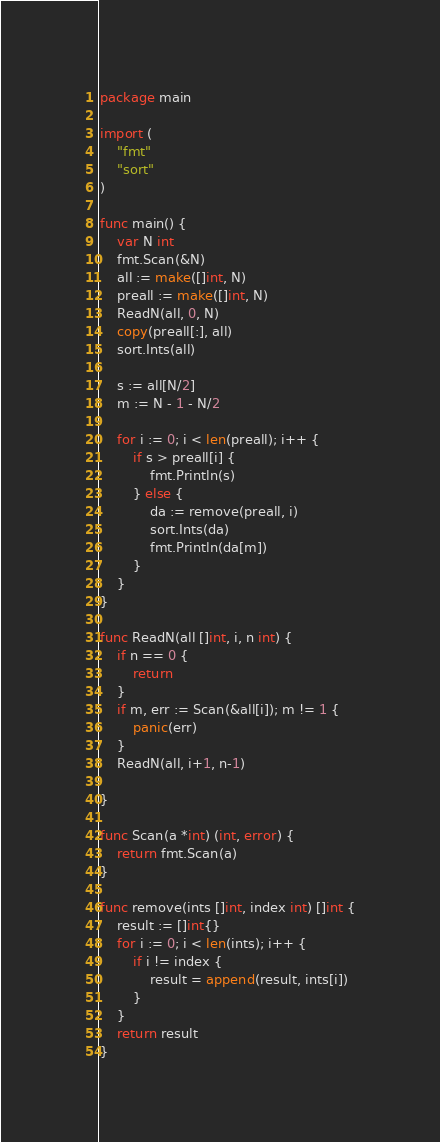Convert code to text. <code><loc_0><loc_0><loc_500><loc_500><_Go_>package main

import (
	"fmt"
	"sort"
)

func main() {
	var N int
	fmt.Scan(&N)
	all := make([]int, N)
	preall := make([]int, N)
	ReadN(all, 0, N)
	copy(preall[:], all)
	sort.Ints(all)

	s := all[N/2]
	m := N - 1 - N/2

	for i := 0; i < len(preall); i++ {
		if s > preall[i] {
			fmt.Println(s)
		} else {
			da := remove(preall, i)
			sort.Ints(da)
			fmt.Println(da[m])
		}
	}
}

func ReadN(all []int, i, n int) {
	if n == 0 {
		return
	}
	if m, err := Scan(&all[i]); m != 1 {
		panic(err)
	}
	ReadN(all, i+1, n-1)

}

func Scan(a *int) (int, error) {
	return fmt.Scan(a)
}

func remove(ints []int, index int) []int {
	result := []int{}
	for i := 0; i < len(ints); i++ {
		if i != index {
			result = append(result, ints[i])
		}
	}
	return result
}</code> 